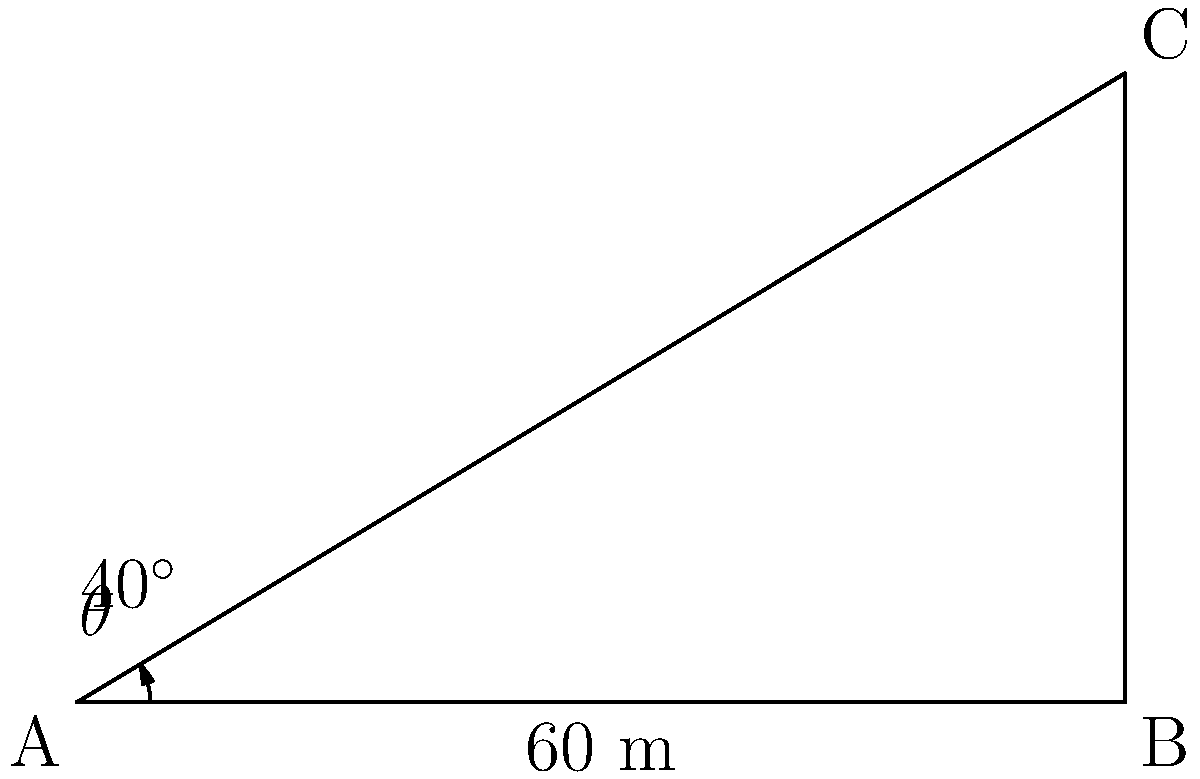You are planning to build a new children's home and need to estimate the height of a nearby building to ensure proper sunlight exposure. Standing 60 meters away from the base of the building, you measure the angle of elevation to the top of the building to be 40°. Calculate the height of the building. Let's approach this step-by-step using trigonometry:

1) We can model this situation as a right-angled triangle, where:
   - The base of the triangle is the distance from where you're standing to the building (60 m)
   - The height of the triangle is the height of the building (what we're trying to find)
   - The angle between the base and the line of sight to the top of the building is 40°

2) In this right-angled triangle, we know:
   - The adjacent side (base) = 60 m
   - The angle = 40°
   - We need to find the opposite side (height)

3) The trigonometric ratio that relates the opposite side to the adjacent side is the tangent:

   $$\tan \theta = \frac{\text{opposite}}{\text{adjacent}}$$

4) Substituting our known values:

   $$\tan 40° = \frac{\text{height}}{60}$$

5) To solve for the height, we multiply both sides by 60:

   $$60 \cdot \tan 40° = \text{height}$$

6) Using a calculator or trigonometric tables:

   $$\text{height} = 60 \cdot \tan 40° \approx 60 \cdot 0.8391 \approx 50.346 \text{ meters}$$

7) Rounding to the nearest meter:

   $$\text{height} \approx 50 \text{ meters}$$
Answer: 50 meters 